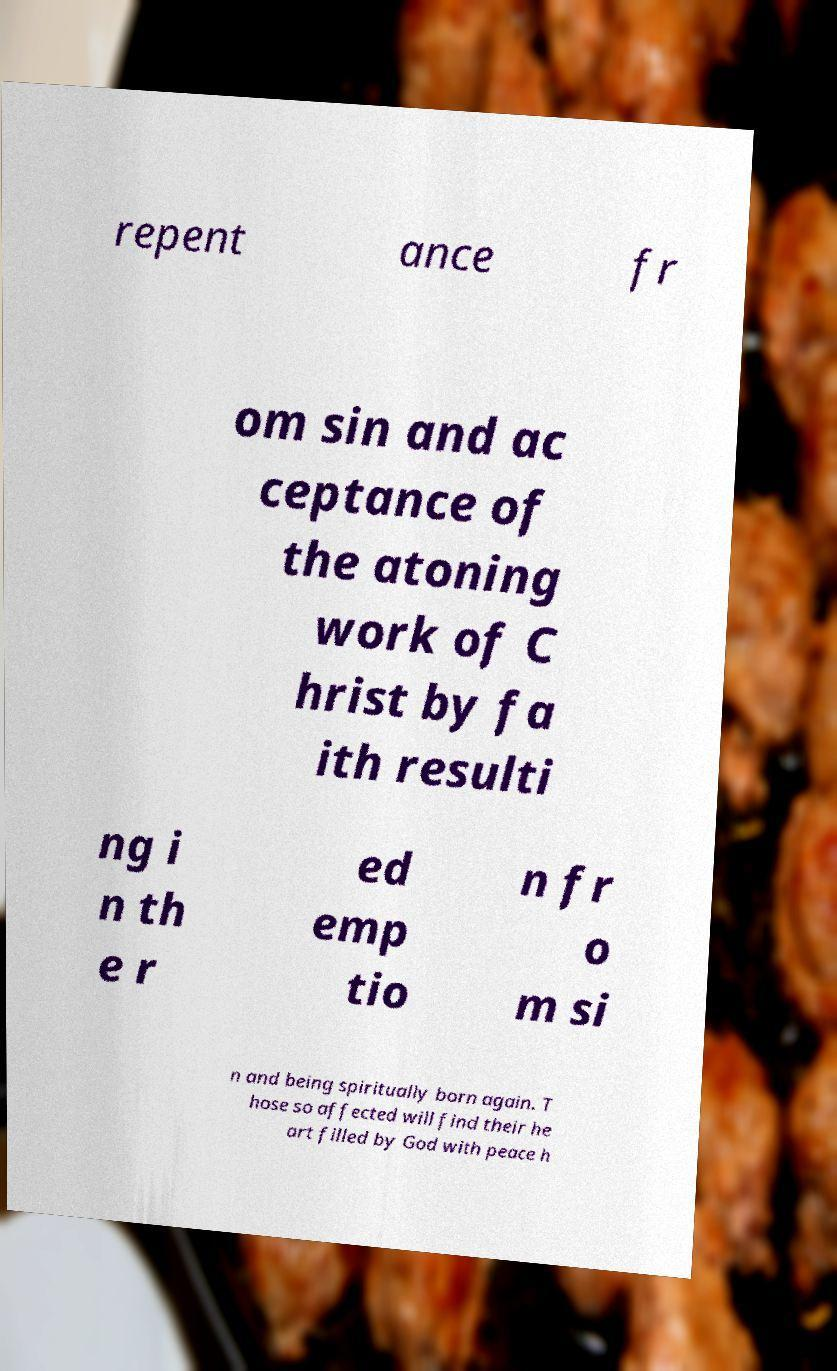For documentation purposes, I need the text within this image transcribed. Could you provide that? repent ance fr om sin and ac ceptance of the atoning work of C hrist by fa ith resulti ng i n th e r ed emp tio n fr o m si n and being spiritually born again. T hose so affected will find their he art filled by God with peace h 